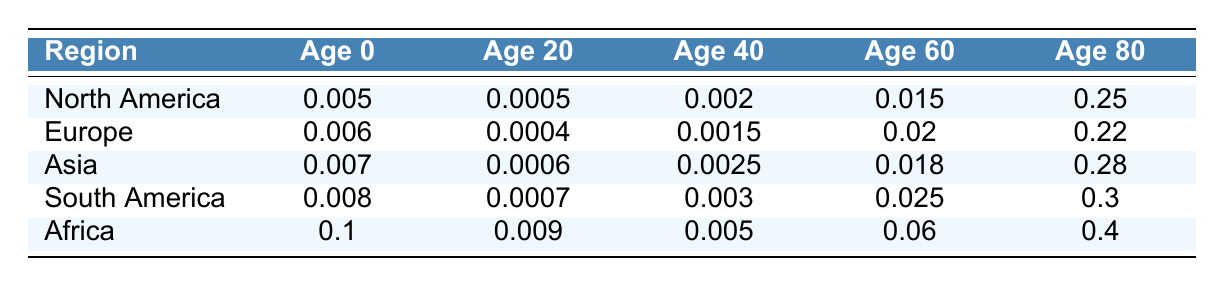What is the mortality rate at age 0 for North America? Referring to the table, the mortality rate at age 0 for North America is listed directly.
Answer: 0.005 What is the mortality rate for individuals aged 80 in Asia? The table indicates the mortality rate for age 80 in the Asia row, which is provided directly.
Answer: 0.28 Which region has the lowest mortality rate at age 20, and what is that rate? By comparing the mortality rates at age 20 from all regions in the table, Europe has the lowest rate of 0.0004.
Answer: Europe, 0.0004 What is the difference between the mortality rates at age 60 for North America and Europe? The mortality rate for North America at age 60 is 0.015 and for Europe it is 0.02. The difference is calculated as 0.02 - 0.015 = 0.005.
Answer: 0.005 Is the mortality rate at age 80 in Africa higher than in South America? By inspecting the table, the mortality rate at age 80 for Africa is 0.4, while for South America it is 0.3. Since 0.4 is greater than 0.3, the statement is true.
Answer: Yes What is the average mortality rate at age 40 across all regions? To find the average, add the mortality rates at age 40 for all regions: 0.002 + 0.0015 + 0.0025 + 0.003 + 0.005 = 0.014. Then, divide by the number of regions (5): 0.014 / 5 = 0.0028.
Answer: 0.0028 Which age group has the highest mortality rate in South America? Looking at the different age groups for South America in the table, the highest mortality rate is at age 80, which is 0.3.
Answer: Age 80 What is the total mortality rate at age 0 across all regions? The total mortality rate at age 0 includes summing up the rates from all regions: 0.005 + 0.006 + 0.007 + 0.008 + 0.1 = 0.126.
Answer: 0.126 In which region is the mortality rate at age 60 the highest? By comparing the mortality rates at age 60 across all regions, Africa has the highest mortality rate at 0.06.
Answer: Africa 